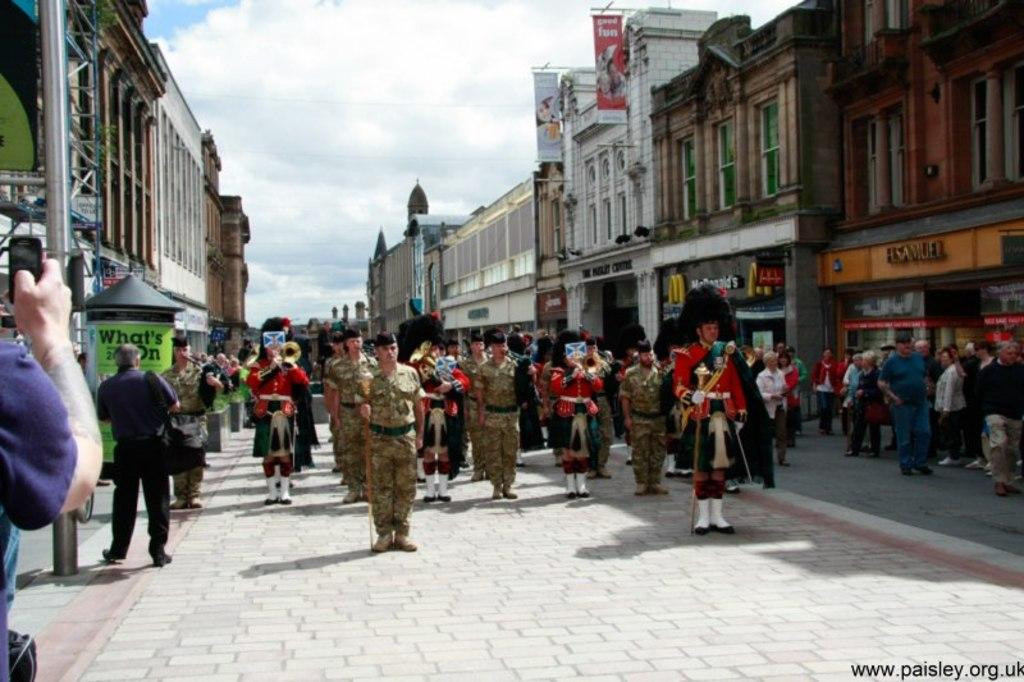What are the people in the image doing? The persons in the image are standing on the road. What can be seen in the background of the image? In the background, there are poles, an iron grill, advertisements, buildings, windows, the sky with clouds, and plants. What type of establishments are present in the background? There are stores in the background. What type of boats can be seen sailing in the background? There are no boats present in the image; it features persons standing on the road and various elements in the background, including poles, an iron grill, advertisements, buildings, windows, the sky with clouds, and plants. 